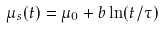Convert formula to latex. <formula><loc_0><loc_0><loc_500><loc_500>\mu _ { s } ( t ) = \mu _ { 0 } + b \ln ( t / \tau )</formula> 